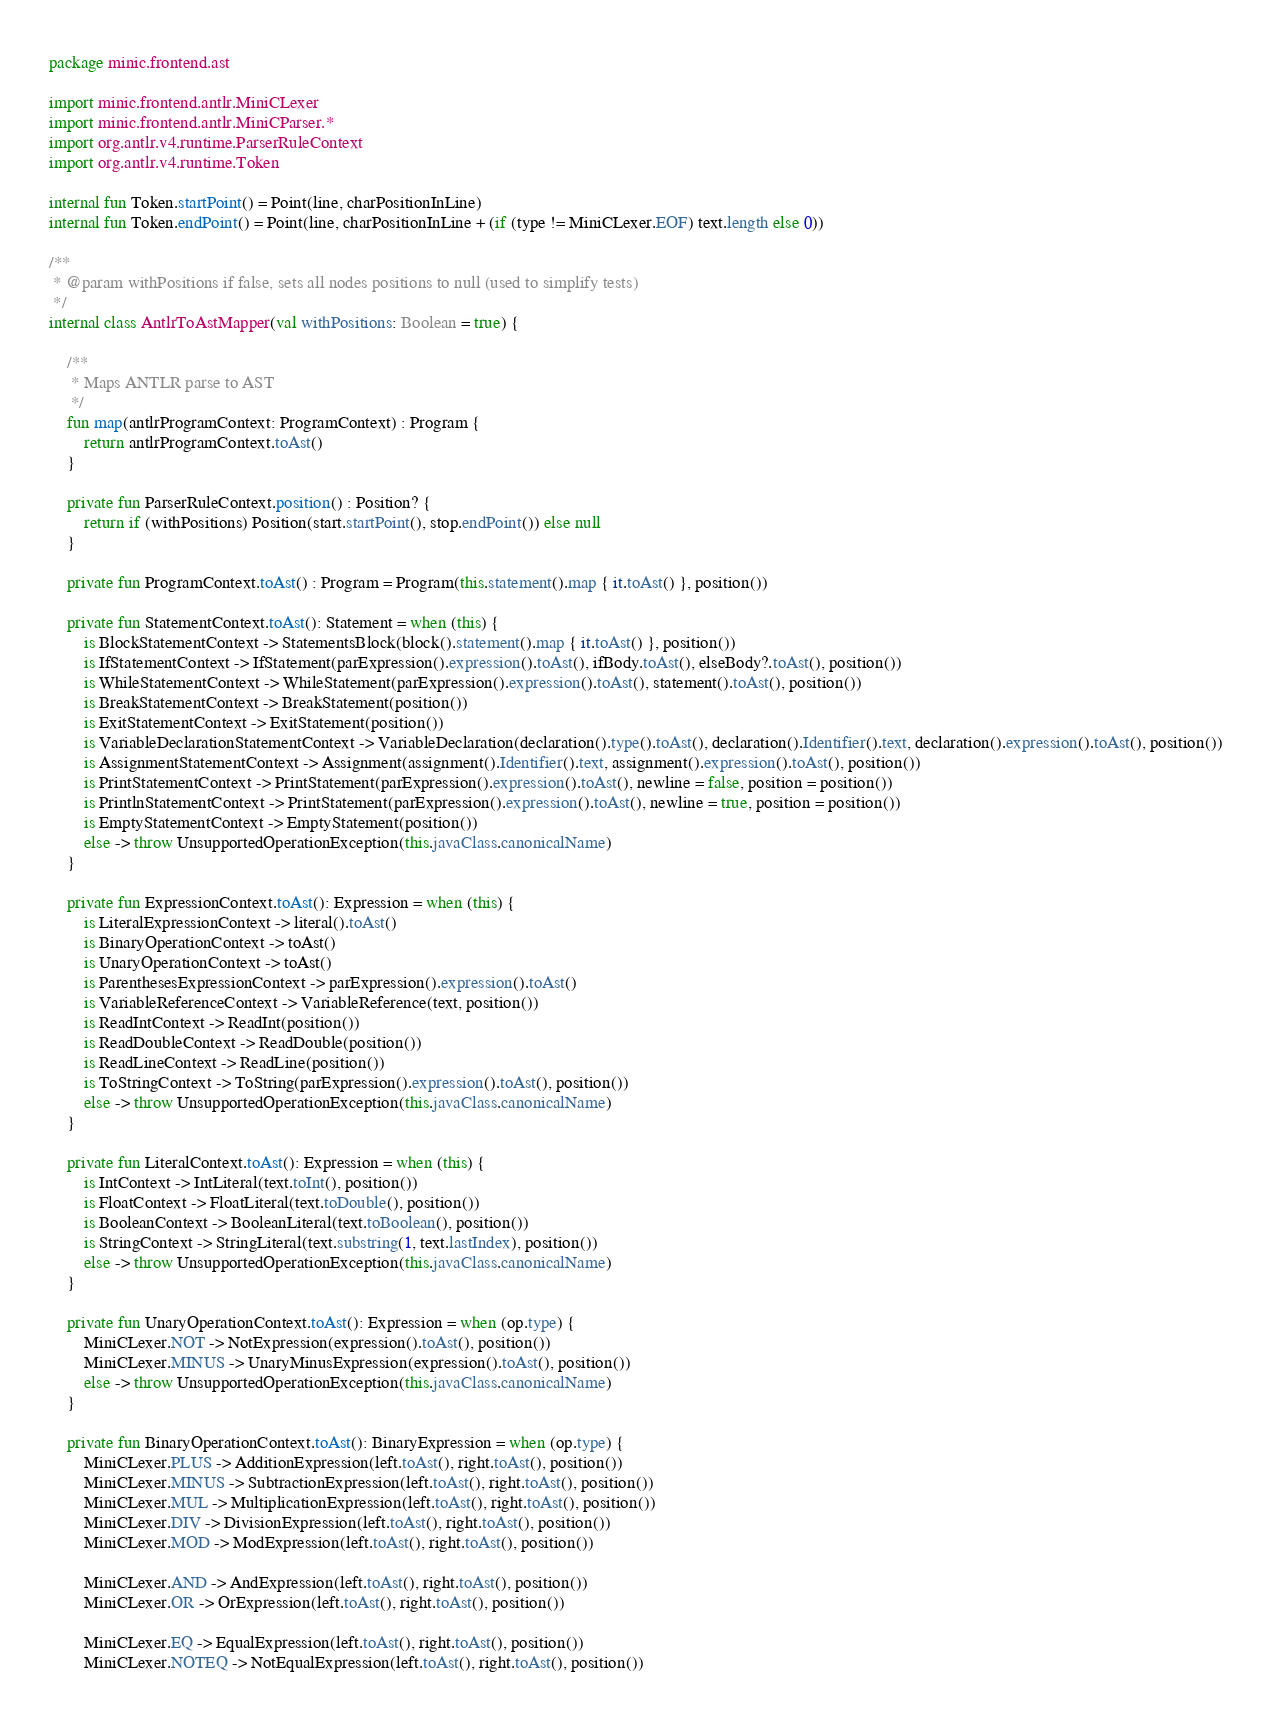Convert code to text. <code><loc_0><loc_0><loc_500><loc_500><_Kotlin_>package minic.frontend.ast

import minic.frontend.antlr.MiniCLexer
import minic.frontend.antlr.MiniCParser.*
import org.antlr.v4.runtime.ParserRuleContext
import org.antlr.v4.runtime.Token

internal fun Token.startPoint() = Point(line, charPositionInLine)
internal fun Token.endPoint() = Point(line, charPositionInLine + (if (type != MiniCLexer.EOF) text.length else 0))

/**
 * @param withPositions if false, sets all nodes positions to null (used to simplify tests)
 */
internal class AntlrToAstMapper(val withPositions: Boolean = true) {

    /**
     * Maps ANTLR parse to AST
     */
    fun map(antlrProgramContext: ProgramContext) : Program {
        return antlrProgramContext.toAst()
    }

    private fun ParserRuleContext.position() : Position? {
        return if (withPositions) Position(start.startPoint(), stop.endPoint()) else null
    }

    private fun ProgramContext.toAst() : Program = Program(this.statement().map { it.toAst() }, position())

    private fun StatementContext.toAst(): Statement = when (this) {
        is BlockStatementContext -> StatementsBlock(block().statement().map { it.toAst() }, position())
        is IfStatementContext -> IfStatement(parExpression().expression().toAst(), ifBody.toAst(), elseBody?.toAst(), position())
        is WhileStatementContext -> WhileStatement(parExpression().expression().toAst(), statement().toAst(), position())
        is BreakStatementContext -> BreakStatement(position())
        is ExitStatementContext -> ExitStatement(position())
        is VariableDeclarationStatementContext -> VariableDeclaration(declaration().type().toAst(), declaration().Identifier().text, declaration().expression().toAst(), position())
        is AssignmentStatementContext -> Assignment(assignment().Identifier().text, assignment().expression().toAst(), position())
        is PrintStatementContext -> PrintStatement(parExpression().expression().toAst(), newline = false, position = position())
        is PrintlnStatementContext -> PrintStatement(parExpression().expression().toAst(), newline = true, position = position())
        is EmptyStatementContext -> EmptyStatement(position())
        else -> throw UnsupportedOperationException(this.javaClass.canonicalName)
    }

    private fun ExpressionContext.toAst(): Expression = when (this) {
        is LiteralExpressionContext -> literal().toAst()
        is BinaryOperationContext -> toAst()
        is UnaryOperationContext -> toAst()
        is ParenthesesExpressionContext -> parExpression().expression().toAst()
        is VariableReferenceContext -> VariableReference(text, position())
        is ReadIntContext -> ReadInt(position())
        is ReadDoubleContext -> ReadDouble(position())
        is ReadLineContext -> ReadLine(position())
        is ToStringContext -> ToString(parExpression().expression().toAst(), position())
        else -> throw UnsupportedOperationException(this.javaClass.canonicalName)
    }

    private fun LiteralContext.toAst(): Expression = when (this) {
        is IntContext -> IntLiteral(text.toInt(), position())
        is FloatContext -> FloatLiteral(text.toDouble(), position())
        is BooleanContext -> BooleanLiteral(text.toBoolean(), position())
        is StringContext -> StringLiteral(text.substring(1, text.lastIndex), position())
        else -> throw UnsupportedOperationException(this.javaClass.canonicalName)
    }

    private fun UnaryOperationContext.toAst(): Expression = when (op.type) {
        MiniCLexer.NOT -> NotExpression(expression().toAst(), position())
        MiniCLexer.MINUS -> UnaryMinusExpression(expression().toAst(), position())
        else -> throw UnsupportedOperationException(this.javaClass.canonicalName)
    }

    private fun BinaryOperationContext.toAst(): BinaryExpression = when (op.type) {
        MiniCLexer.PLUS -> AdditionExpression(left.toAst(), right.toAst(), position())
        MiniCLexer.MINUS -> SubtractionExpression(left.toAst(), right.toAst(), position())
        MiniCLexer.MUL -> MultiplicationExpression(left.toAst(), right.toAst(), position())
        MiniCLexer.DIV -> DivisionExpression(left.toAst(), right.toAst(), position())
        MiniCLexer.MOD -> ModExpression(left.toAst(), right.toAst(), position())

        MiniCLexer.AND -> AndExpression(left.toAst(), right.toAst(), position())
        MiniCLexer.OR -> OrExpression(left.toAst(), right.toAst(), position())

        MiniCLexer.EQ -> EqualExpression(left.toAst(), right.toAst(), position())
        MiniCLexer.NOTEQ -> NotEqualExpression(left.toAst(), right.toAst(), position())</code> 